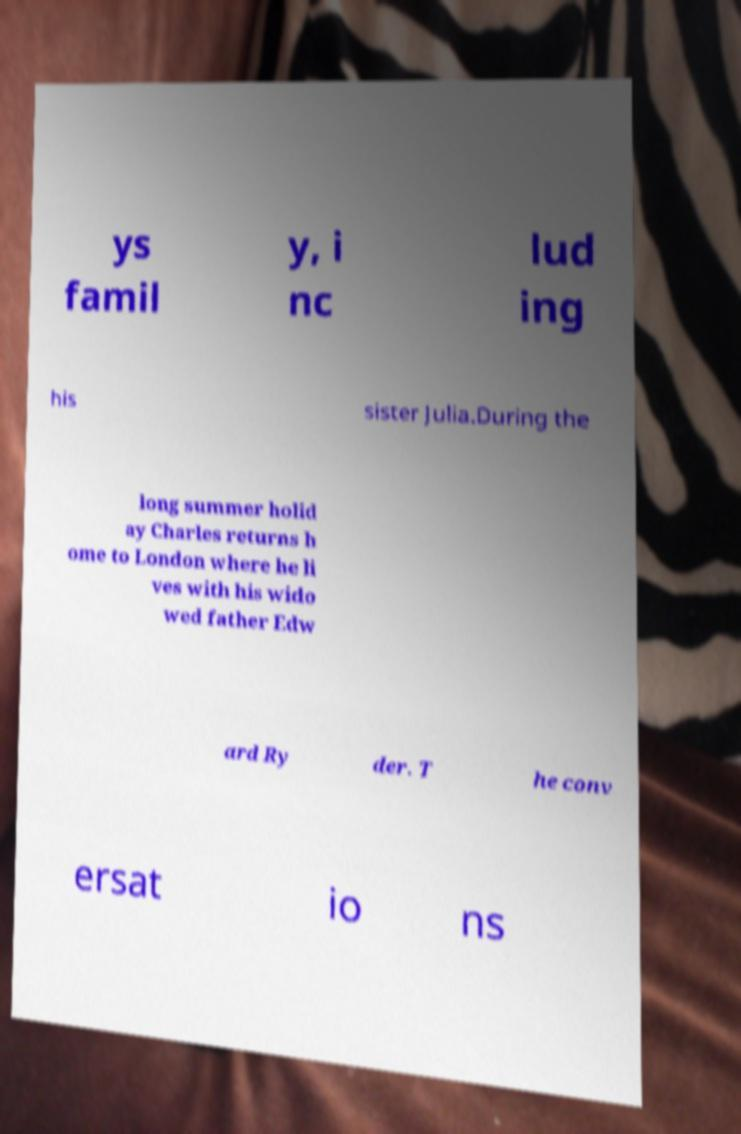Can you read and provide the text displayed in the image?This photo seems to have some interesting text. Can you extract and type it out for me? ys famil y, i nc lud ing his sister Julia.During the long summer holid ay Charles returns h ome to London where he li ves with his wido wed father Edw ard Ry der. T he conv ersat io ns 